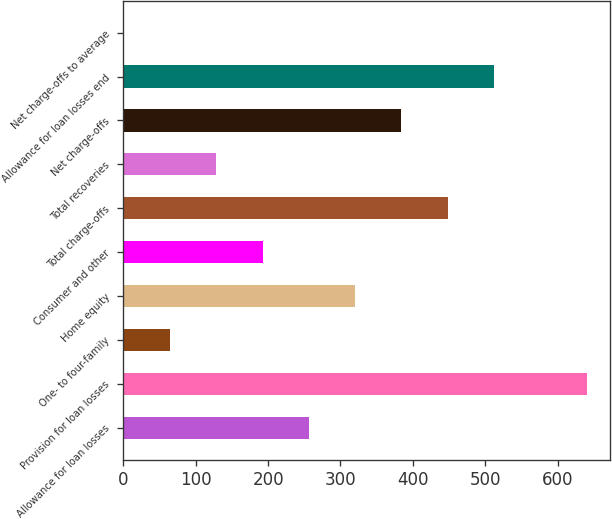Convert chart to OTSL. <chart><loc_0><loc_0><loc_500><loc_500><bar_chart><fcel>Allowance for loan losses<fcel>Provision for loan losses<fcel>One- to four-family<fcel>Home equity<fcel>Consumer and other<fcel>Total charge-offs<fcel>Total recoveries<fcel>Net charge-offs<fcel>Allowance for loan losses end<fcel>Net charge-offs to average<nl><fcel>256.44<fcel>640.1<fcel>64.6<fcel>320.38<fcel>192.5<fcel>448.26<fcel>128.55<fcel>384.32<fcel>512.21<fcel>0.65<nl></chart> 